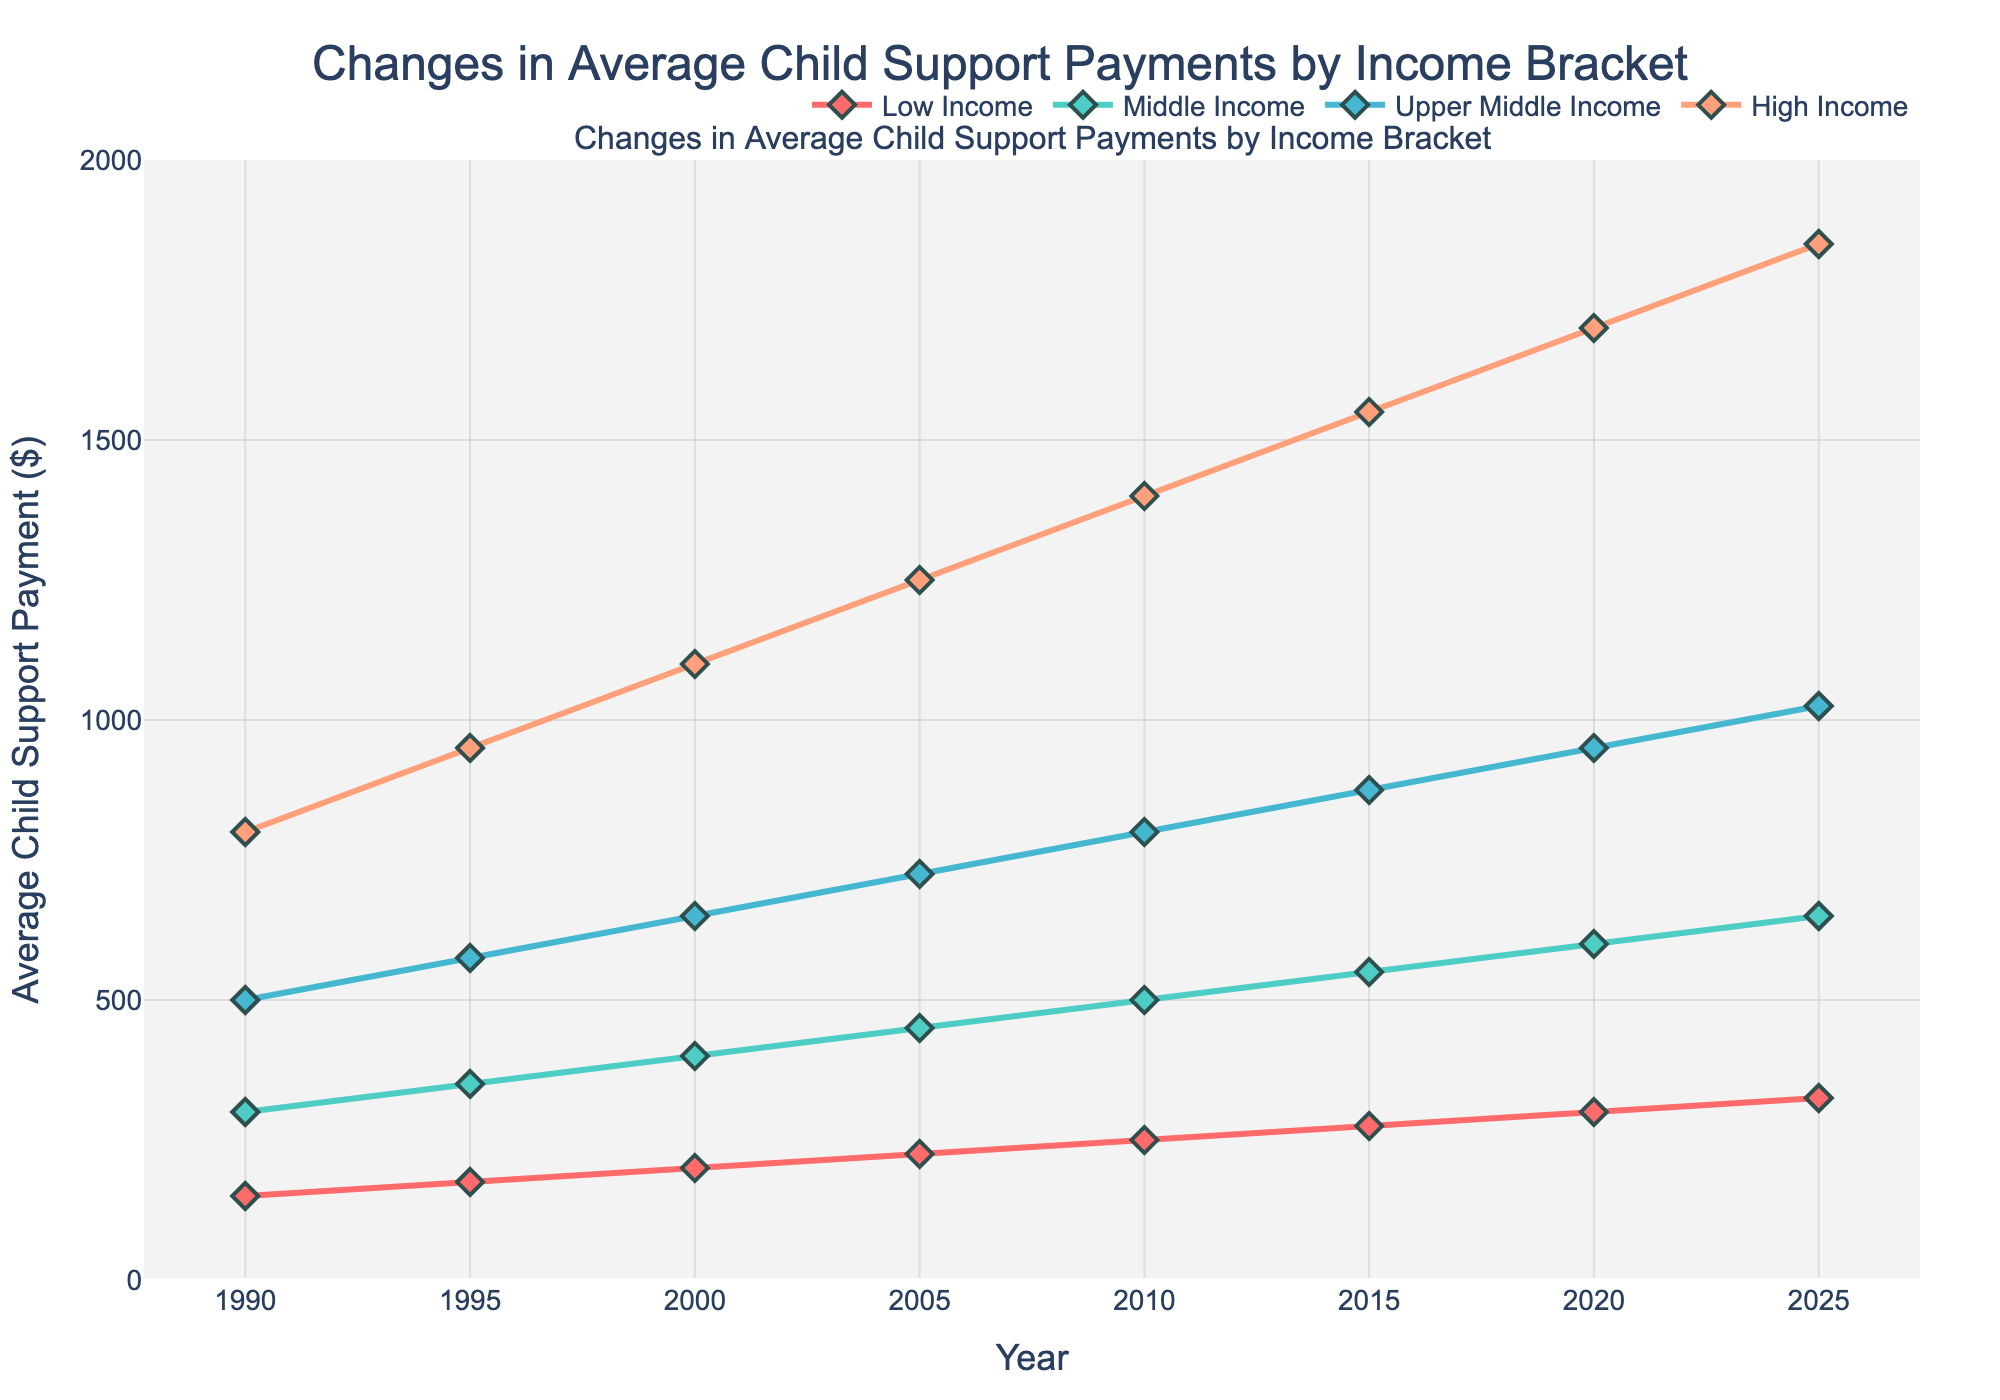Which income bracket had the highest average child support payment in 2020? The highest line value in 2020 corresponds to the High Income bracket with an average child support payment of $1700.
Answer: High Income What was the increase in average child support payment for the Low Income bracket from 1990 to 2020? The average child support payment for Low Income in 1990 was $150, and in 2020 it was $300. The increase is $300 - $150 = $150.
Answer: $150 Which income bracket showed the most consistent growth in average child support payments over the years? The plot shows that all brackets have increased, but High Income shows a quite consistent and significant increase without fluctuations.
Answer: High Income By how much did the average child support payment for the Middle Income bracket change between 1990 and 2015? The average payment for the Middle Income bracket was $300 in 1990 and $550 in 2015. The change is $550 - $300 = $250.
Answer: $250 What is the color of the line representing the Upper Middle Income bracket? The Upper Middle Income bracket line is represented in blue.
Answer: Blue Between which years did the High Income bracket see the largest increase in average child support payments? The High Income bracket increased from $1400 in 2010 to $1550 in 2015, a span of 150, and from $1550 in 2015 to $1700 in 2020, also a span of 150. Thus, there are two intervals with equal increases.
Answer: 2010-2015 and 2015-2020 By what percentage did the average child support payment for the High Income bracket increase from 1990 to 2025? The average payment went from $800 in 1990 to $1850 in 2025. The percentage increase is ((1850 - 800) / 800) * 100 = 131.25%.
Answer: 131.25% How does the trend in average child support payments for the Low Income bracket compare to the Middle Income bracket? Both show a steady increase; however, the Middle Income bracket starts and ends at higher values compared to the Low Income bracket.
Answer: Both rise steadily, with Middle Income always higher What is the difference in average child support payments between the upper middle income and highest income bracket for the year 2020? In 2020, the upper middle income bracket was $950 and high income was $1700. The difference is $1700 - $950 = $750.
Answer: $750 By how much did the average child support payment for Middle Income grow from 2015 to 2020? The average payment for Middle Income was $550 in 2015 and increased to $600 in 2020. The growth is $600 - $550 = $50.
Answer: $50 